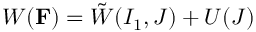<formula> <loc_0><loc_0><loc_500><loc_500>W ( F ) = \tilde { W } ( I _ { 1 } , J ) + U ( J )</formula> 